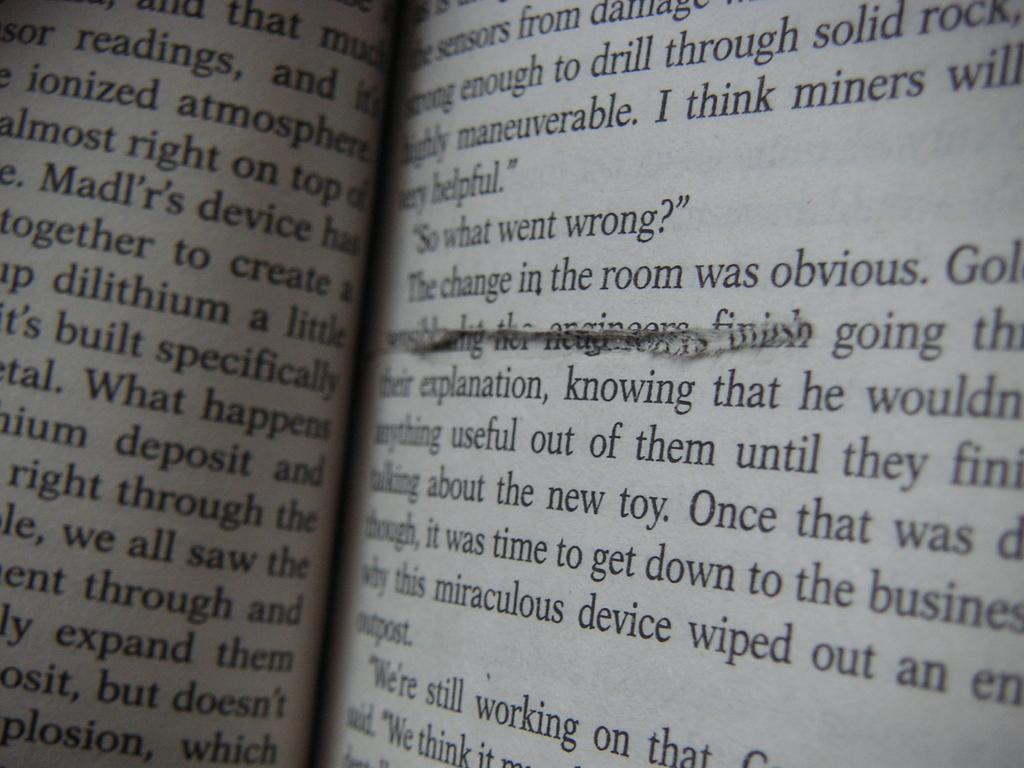<image>
Offer a succinct explanation of the picture presented. An open book with a cut on the page below the line that reads "the change in the room wa obvious." 